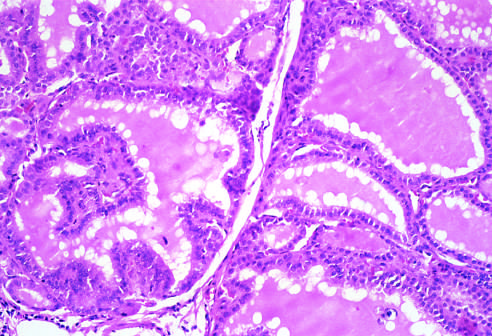what are the follicles lined by?
Answer the question using a single word or phrase. Tall columnar epithelial cells 